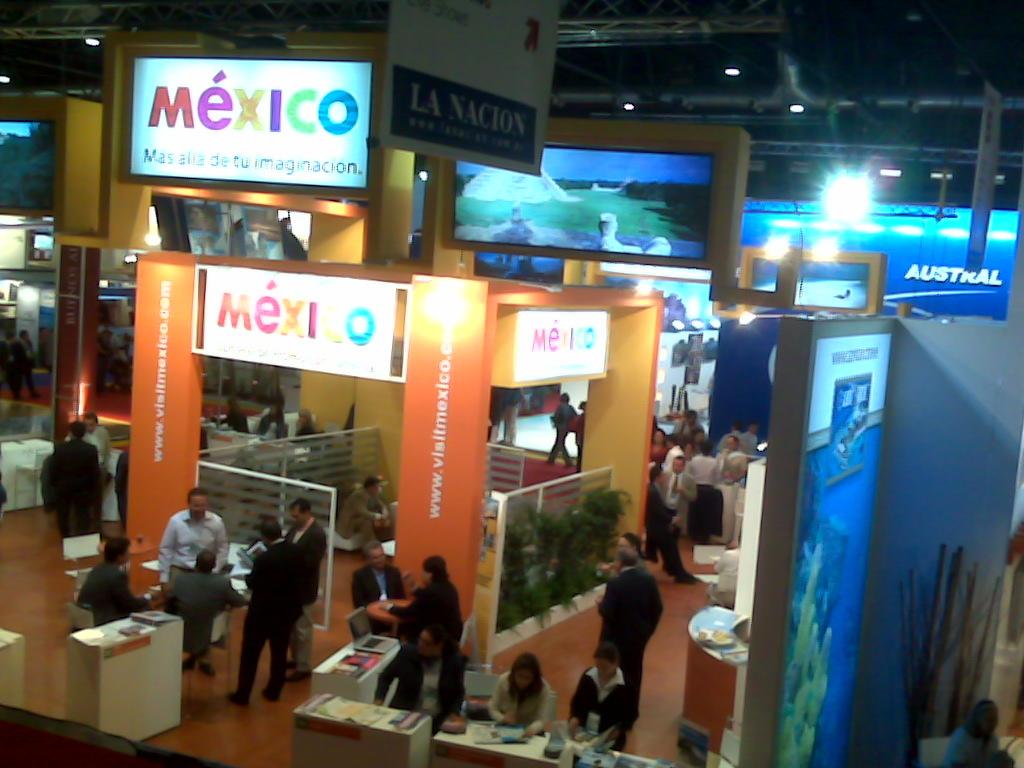What is written in white on the blue wall in the back?
Make the answer very short. Austral. What country is this?
Your answer should be compact. Mexico. 